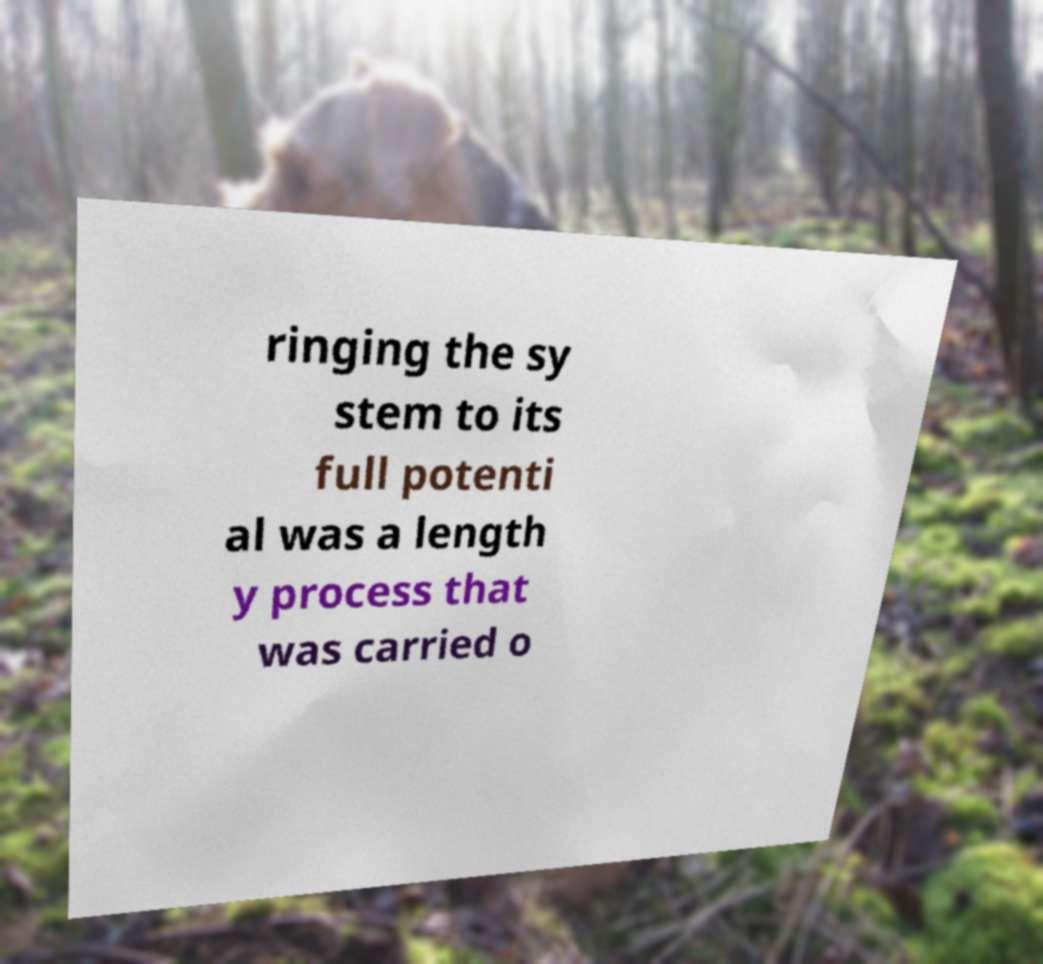There's text embedded in this image that I need extracted. Can you transcribe it verbatim? ringing the sy stem to its full potenti al was a length y process that was carried o 